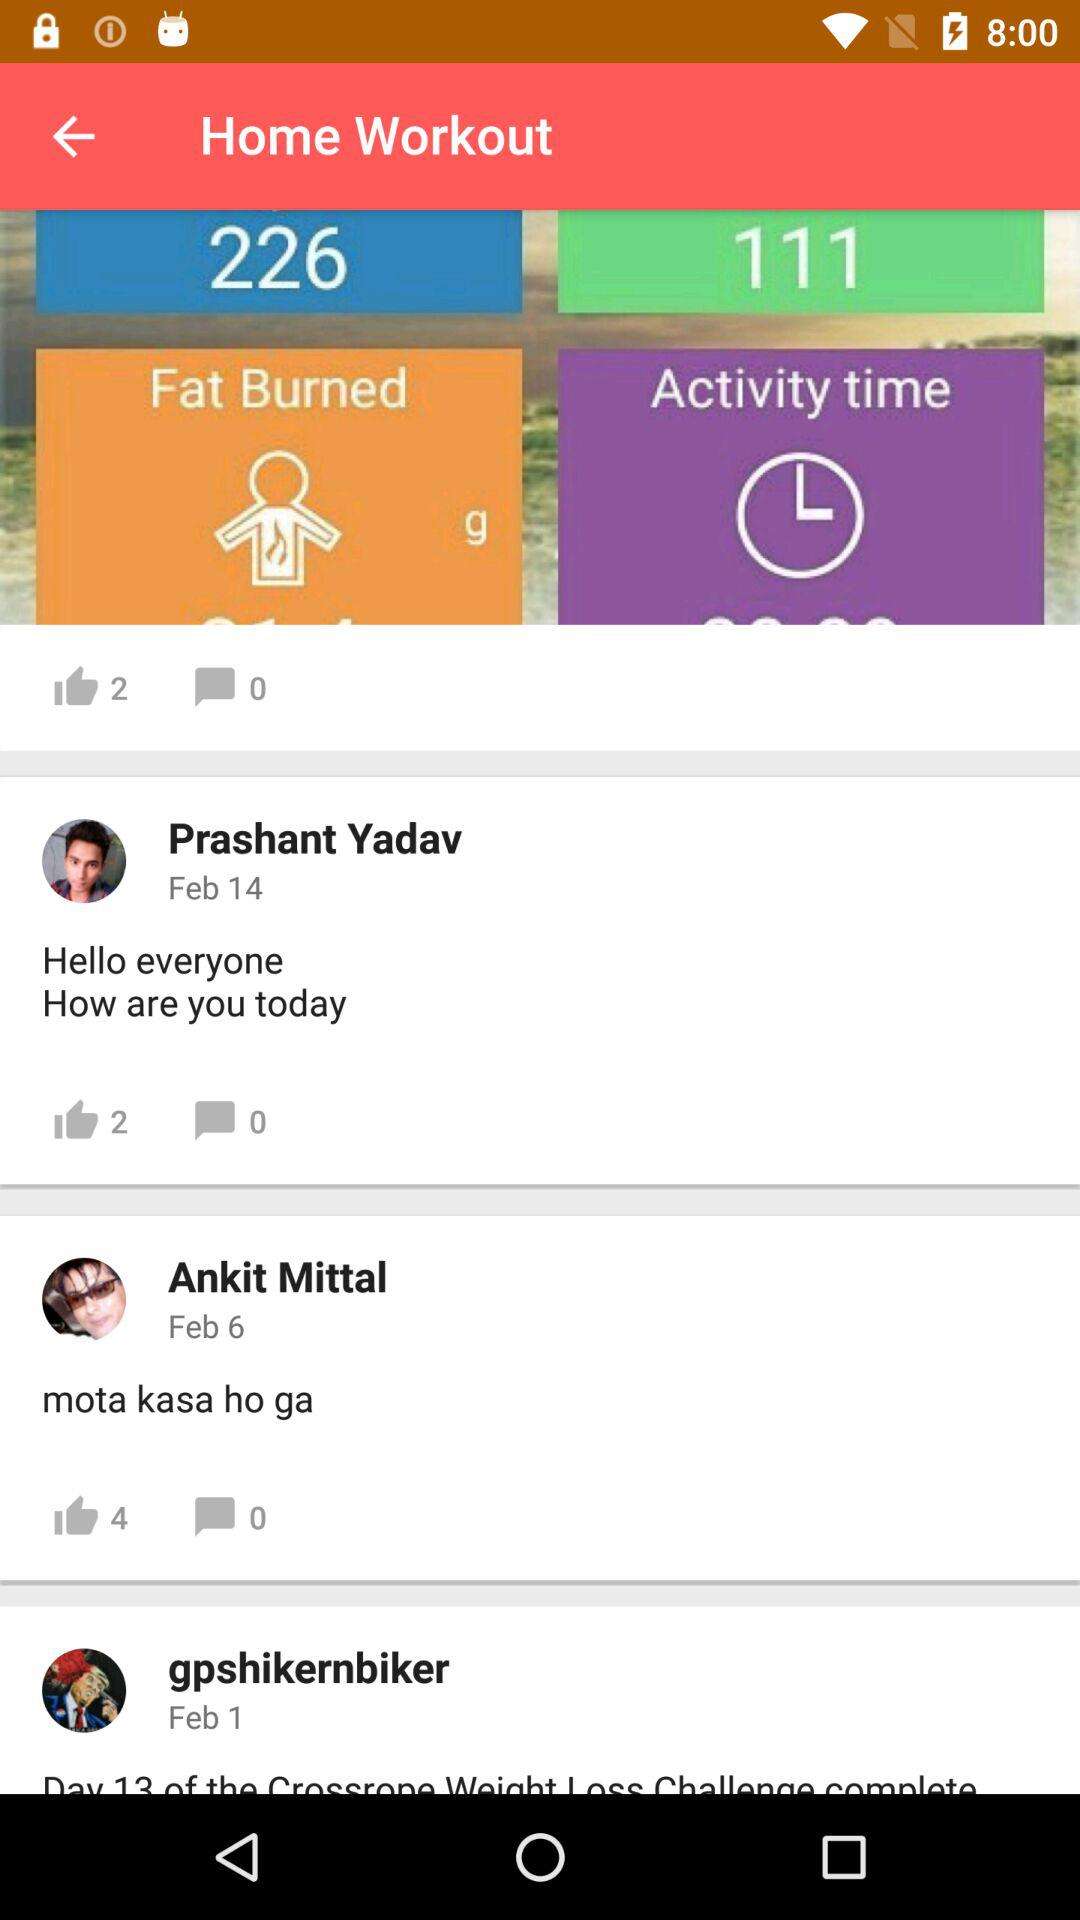How much fat is burned?
When the provided information is insufficient, respond with <no answer>. <no answer> 